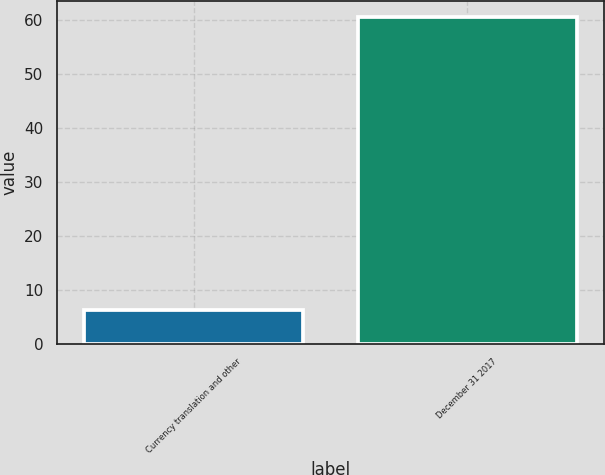Convert chart. <chart><loc_0><loc_0><loc_500><loc_500><bar_chart><fcel>Currency translation and other<fcel>December 31 2017<nl><fcel>6.2<fcel>60.6<nl></chart> 